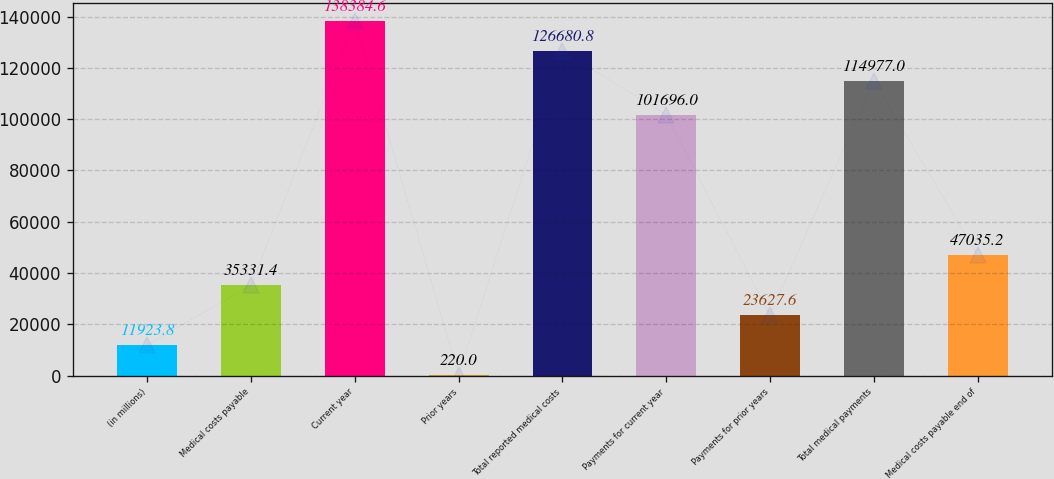Convert chart. <chart><loc_0><loc_0><loc_500><loc_500><bar_chart><fcel>(in millions)<fcel>Medical costs payable<fcel>Current year<fcel>Prior years<fcel>Total reported medical costs<fcel>Payments for current year<fcel>Payments for prior years<fcel>Total medical payments<fcel>Medical costs payable end of<nl><fcel>11923.8<fcel>35331.4<fcel>138385<fcel>220<fcel>126681<fcel>101696<fcel>23627.6<fcel>114977<fcel>47035.2<nl></chart> 